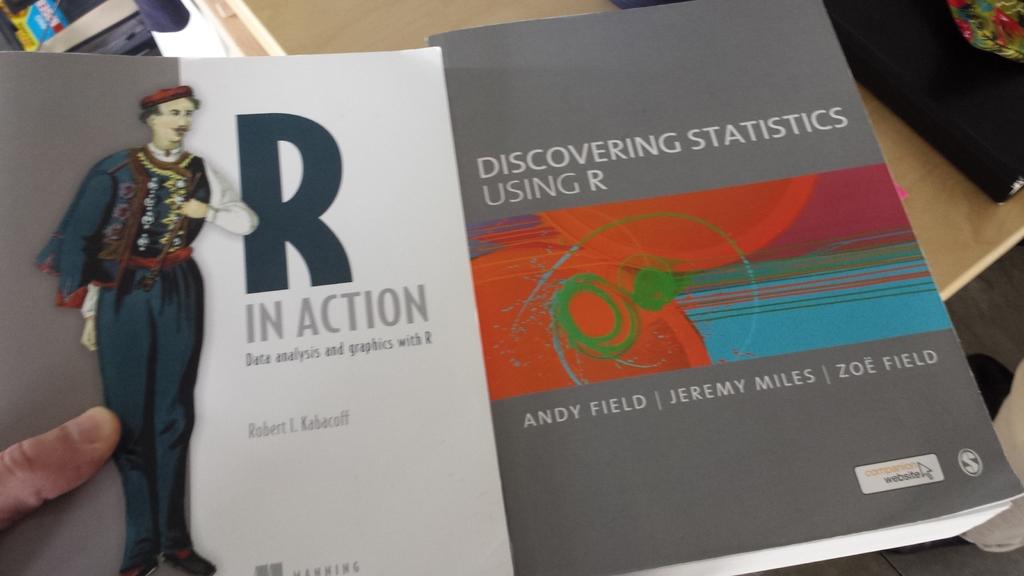What can we discover using r?
Your answer should be very brief. Statistics. 